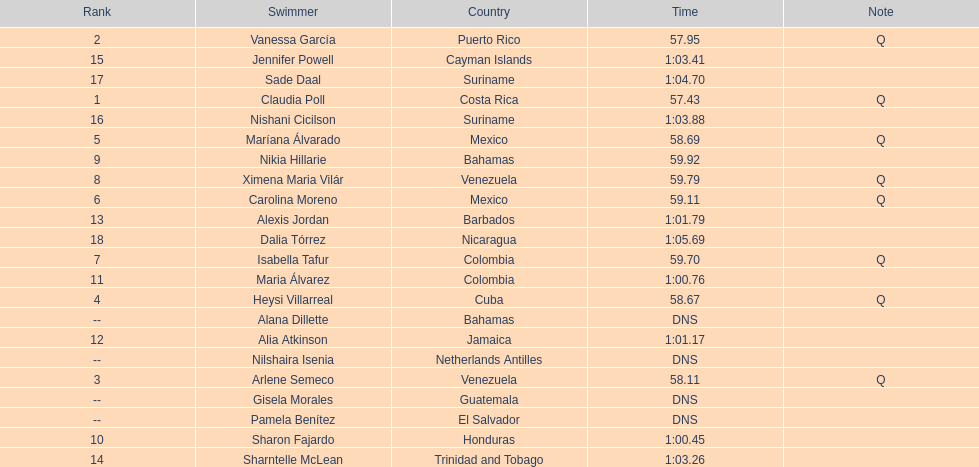How many competitors did not start the preliminaries? 4. 